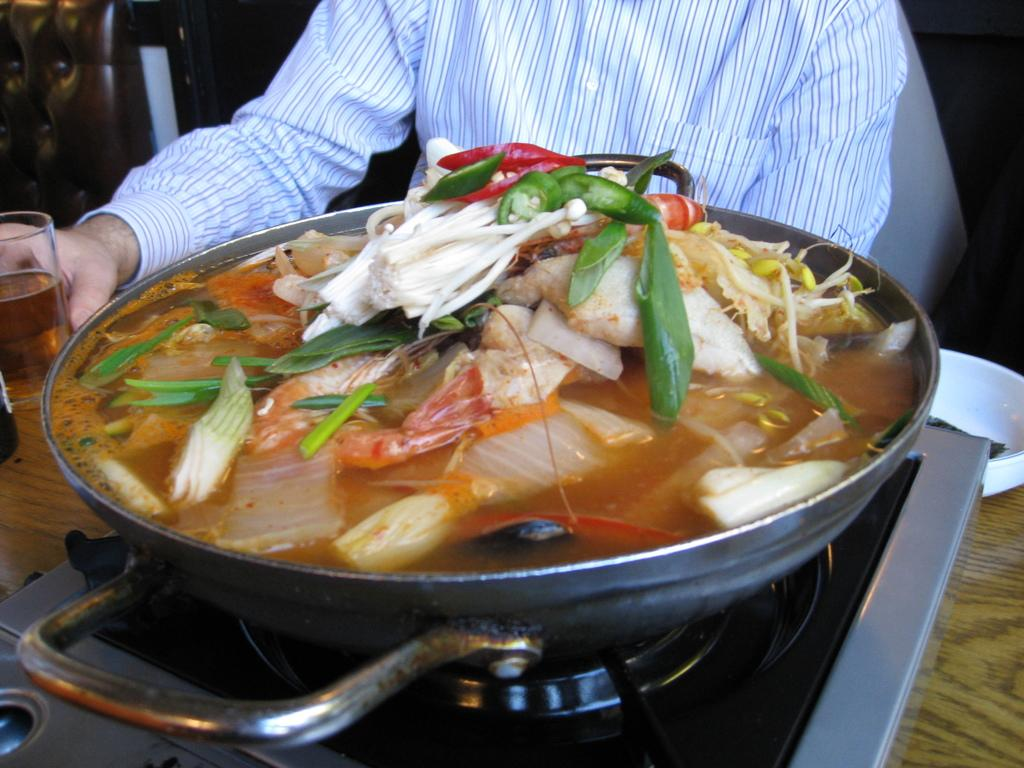What is the person holding in the image? The person is holding a glass with a drink. What is in front of the person on the table? There is a container with food in front of the person. What cooking appliance can be seen in the image? There is a stove in the image. What else is on the table besides the container with food? There is a bowl and another glass on the table. How would you describe the lighting in the image? The background of the image is dark. What type of memory is stored in the glass on the table? There is no memory stored in the glass on the table; it is a glass containing a drink. Is the stove made of plastic in the image? The facts provided do not mention the material of the stove, but there is no indication that it is made of plastic. 